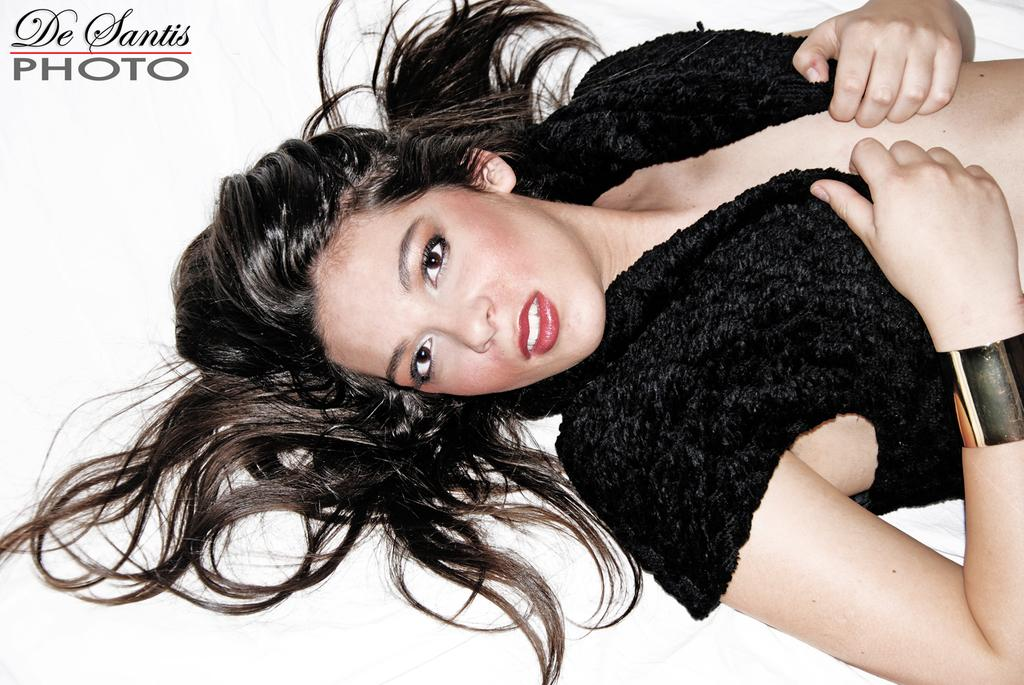Who is present in the image? There is a woman in the image. What is the woman doing in the image? The woman is lying down on a surface. What type of loaf is the woman holding in the image? There is no loaf present in the image; the woman is simply lying down on a surface. 